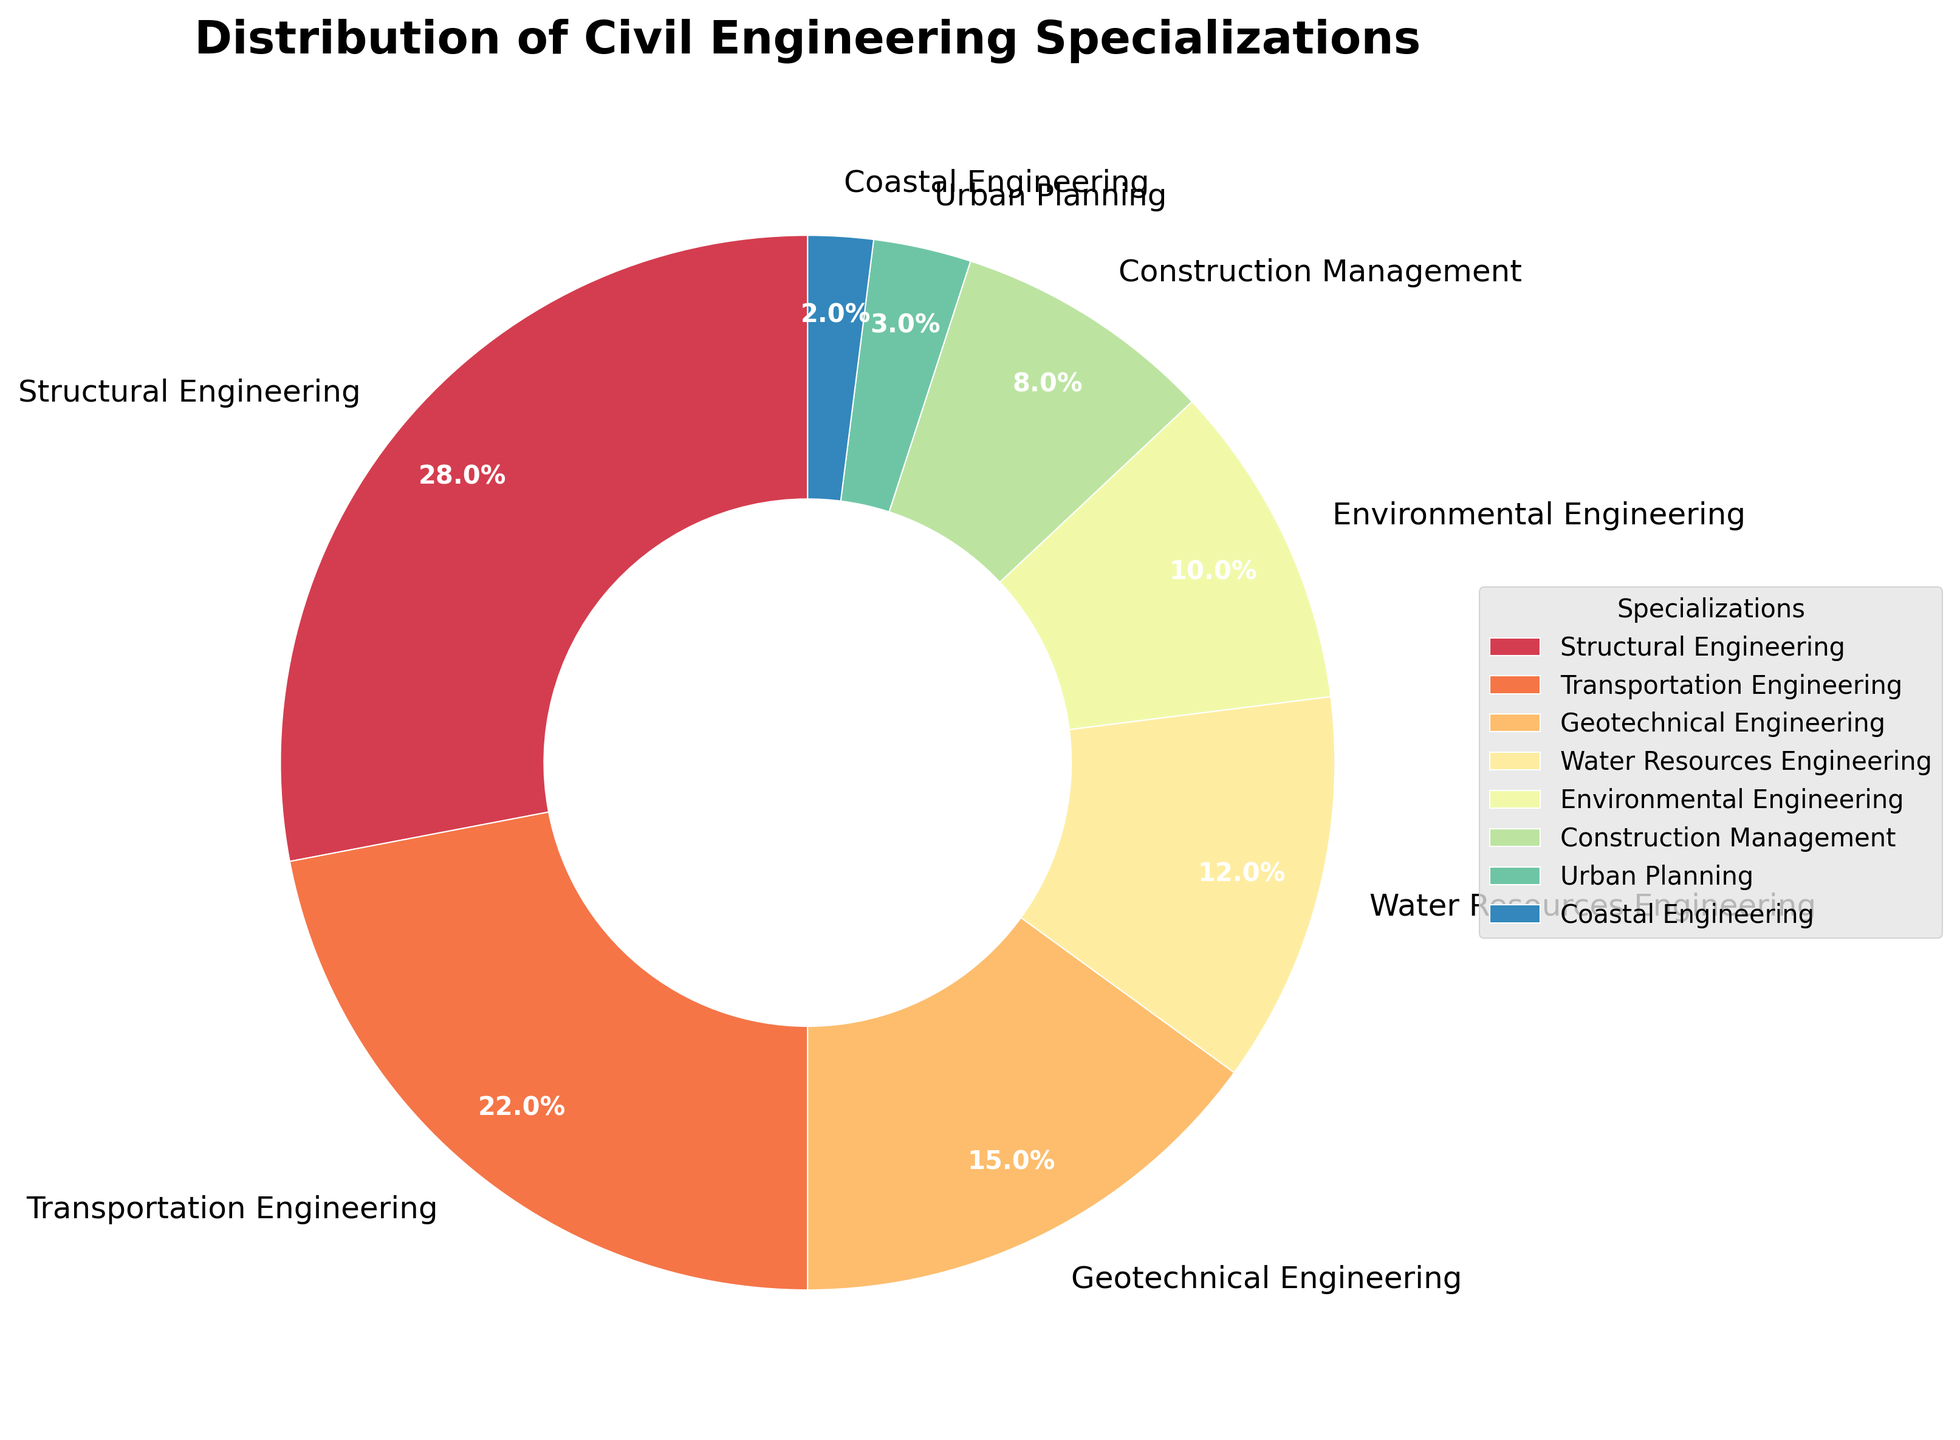What percentage of the job market do Structural and Transportation Engineering together hold? Add the percentages of Structural Engineering (28%) and Transportation Engineering (22%). 28% + 22% = 50%
Answer: 50% Which specialization has the lowest percentage in the job market? The pie chart shows the percentage distribution of each specialization. The smallest wedge represents Coastal Engineering with 2%.
Answer: Coastal Engineering What is the difference in job market percentage between Geotechnical Engineering and Environmental Engineering? Subtract the percentage of Environmental Engineering (10%) from Geotechnical Engineering (15%). 15% - 10% = 5%
Answer: 5% Are there any specializations that together make up more than half of the job market? If so, which ones? Structural Engineering and Transportation Engineering together make up 50%, which is not more than half. Adding Geotechnical Engineering to these two gives 65%, which is more than half. So, the combined group of Structural, Transportation, and Geotechnical Engineering make up more than half.
Answer: Structural, Transportation, and Geotechnical Engineering What visual element indicates the largest specialization on the pie chart? The largest specialization is represented by the biggest wedge, which corresponds to Structural Engineering with 28%.
Answer: The largest wedge for Structural Engineering How much larger is the percentage of Water Resources Engineering compared to Urban Planning? Subtract the percentage of Urban Planning (3%) from Water Resources Engineering (12%). 12% - 3% = 9%
Answer: 9% Which specializations together have the same percentage as Water Resources Engineering? Environmental Engineering (10%) and Coastal Engineering (2%) together make up 10% + 2% = 12%, which matches Water Resources Engineering.
Answer: Environmental and Coastal Engineering What is the combined percentage of the four least represented specializations? Add the percentages of Urban Planning (3%), Coastal Engineering (2%), Construction Management (8%), and Environmental Engineering (10%). 3% + 2% + 8% + 10% = 23%
Answer: 23% Which segment on the pie chart is marked with a color most similar to red? The pie chart uses colors from a range, but the wedge for Structural Engineering appears close to red based on the color scheme used.
Answer: Structural Engineering Which has a higher percentage in the job market: Water Resources Engineering or Construction Management? Compare the percentages: Water Resources Engineering has 12%, while Construction Management has 8%. 12% > 8%
Answer: Water Resources Engineering 